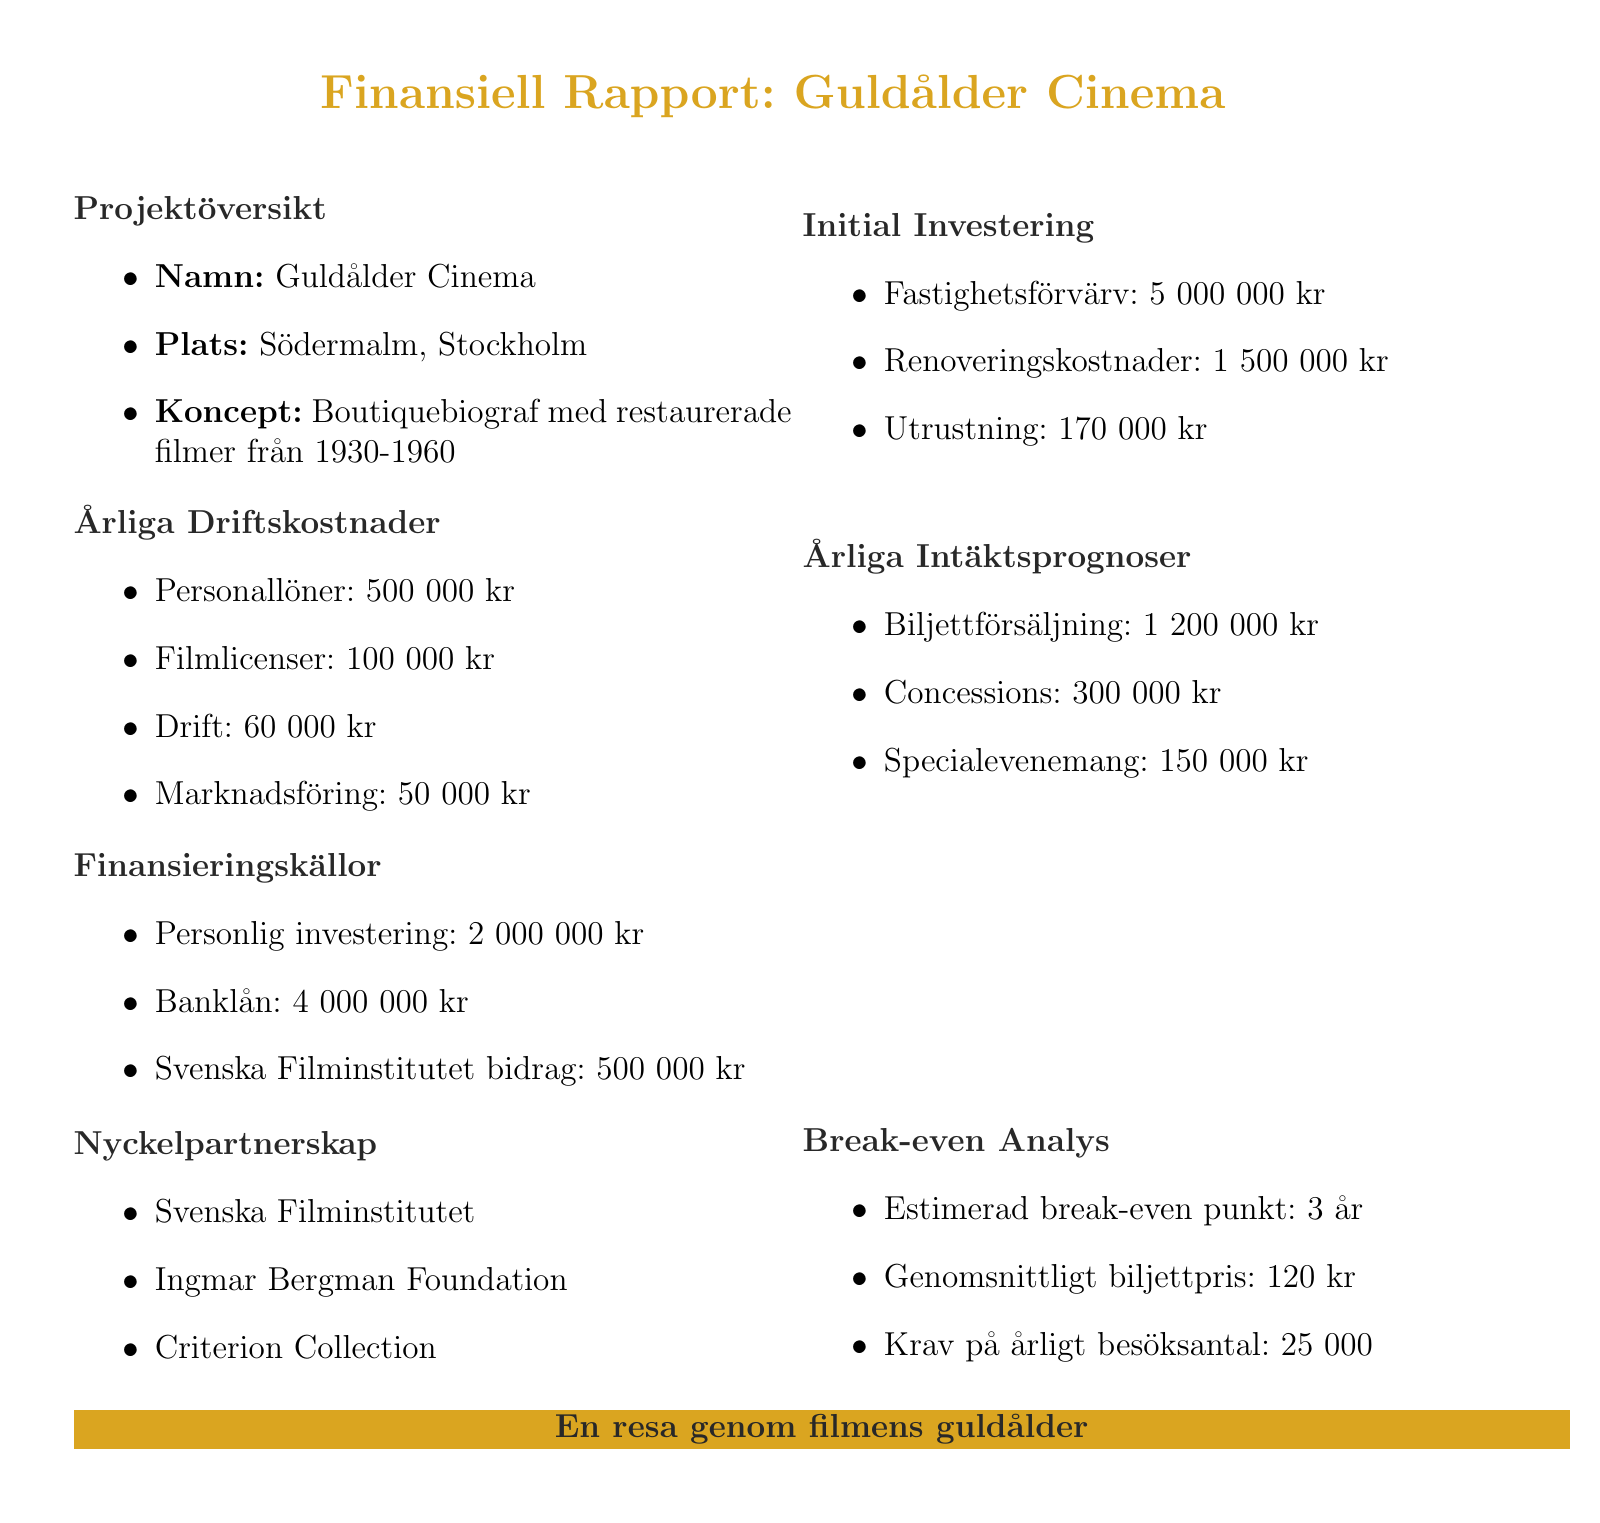what is the name of the cinema? The name of the cinema is stated explicitly in the project overview section of the document.
Answer: Guldålder Cinema where is the cinema located? The location of the cinema is included in the project overview section of the document.
Answer: Södermalm, Stockholm what is the total initial investment? The total initial investment can be calculated by adding property acquisition, renovation costs, and equipment costs listed in the document.
Answer: 6660000 kr how much are the staff salaries annually? The staff salaries are outlined in the operational costs yearly section of the document.
Answer: 500000 kr what is the estimated break-even point? The estimated break-even point is provided in the break-even analysis section of the document.
Answer: 3 years how much is the average ticket price? The average ticket price is mentioned in the break-even analysis section of the document.
Answer: 120 kr what is the required yearly attendance to break even? The required yearly attendance figure is stated in the break-even analysis section of the document.
Answer: 25000 how much total revenue is projected from ticket sales? The projected revenue from ticket sales is specified in the revenue projections yearly section of the document.
Answer: 1200000 kr who are the key partnerships listed? The key partnerships are explicitly listed in the key partnerships section of the document.
Answer: Svenska Filminstitutet, Ingmar Bergman Foundation, Criterion Collection 